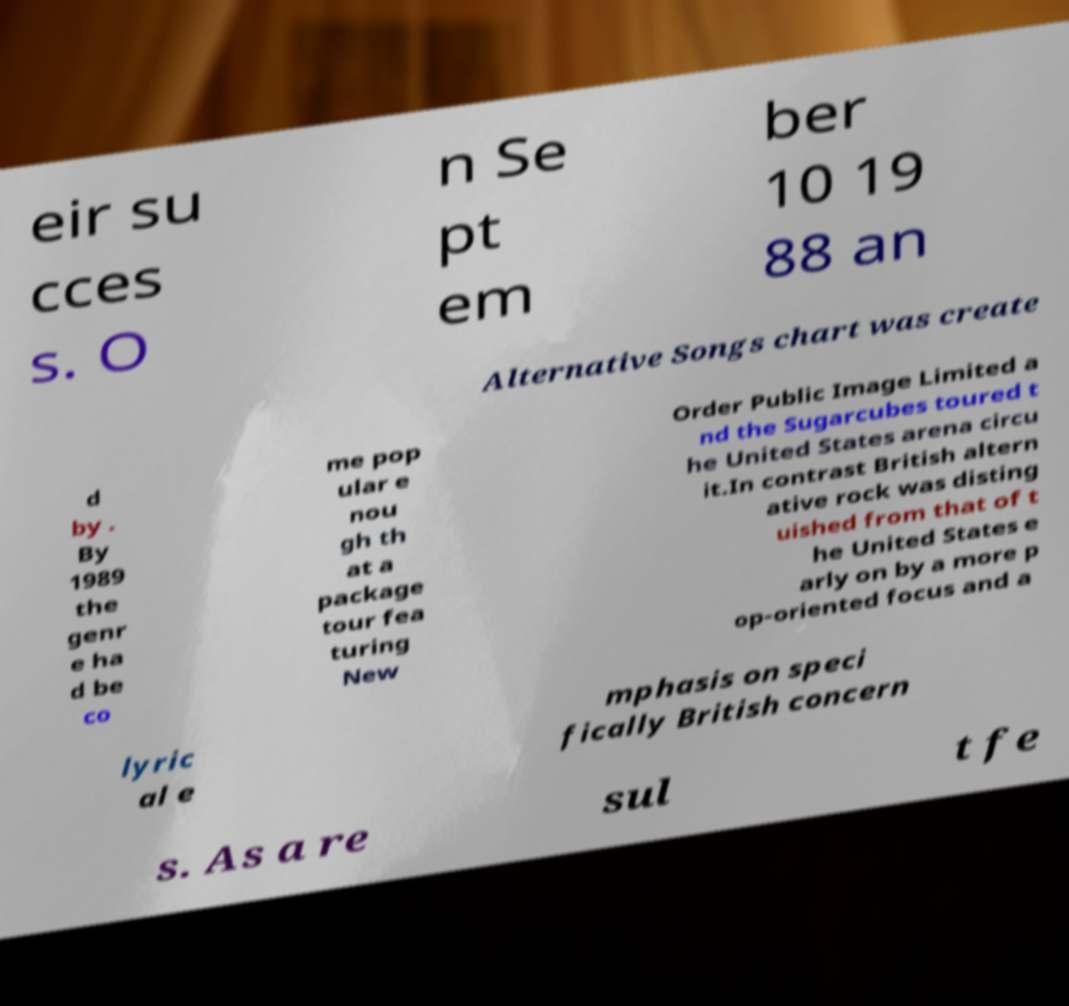Please read and relay the text visible in this image. What does it say? eir su cces s. O n Se pt em ber 10 19 88 an Alternative Songs chart was create d by . By 1989 the genr e ha d be co me pop ular e nou gh th at a package tour fea turing New Order Public Image Limited a nd the Sugarcubes toured t he United States arena circu it.In contrast British altern ative rock was disting uished from that of t he United States e arly on by a more p op-oriented focus and a lyric al e mphasis on speci fically British concern s. As a re sul t fe 